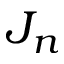Convert formula to latex. <formula><loc_0><loc_0><loc_500><loc_500>J _ { n }</formula> 